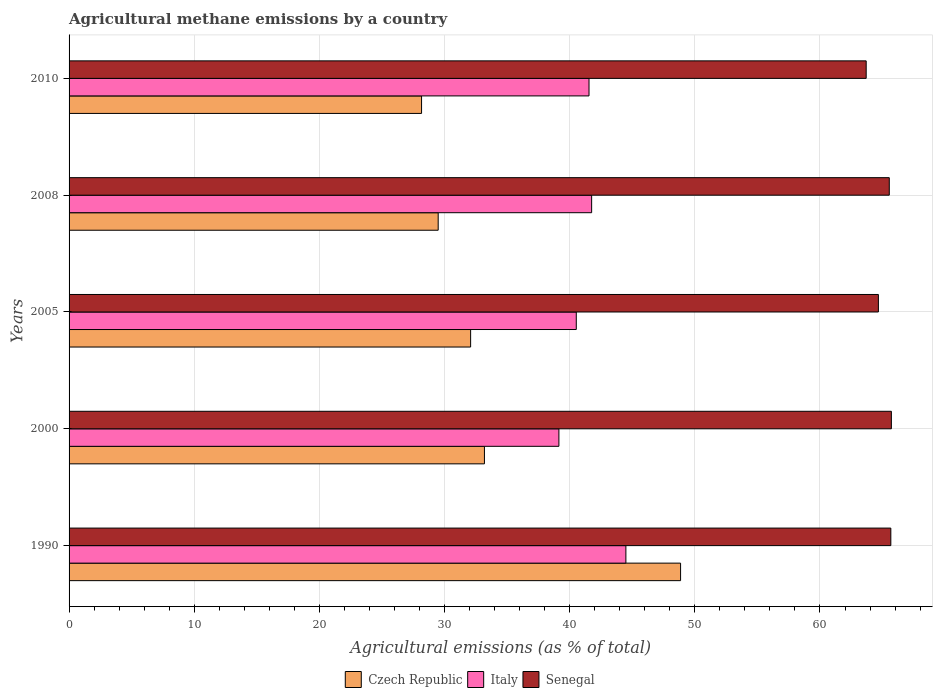How many groups of bars are there?
Your answer should be compact. 5. Are the number of bars on each tick of the Y-axis equal?
Make the answer very short. Yes. How many bars are there on the 4th tick from the bottom?
Give a very brief answer. 3. What is the amount of agricultural methane emitted in Senegal in 2000?
Offer a terse response. 65.71. Across all years, what is the maximum amount of agricultural methane emitted in Italy?
Give a very brief answer. 44.49. Across all years, what is the minimum amount of agricultural methane emitted in Italy?
Ensure brevity in your answer.  39.14. In which year was the amount of agricultural methane emitted in Czech Republic maximum?
Provide a short and direct response. 1990. What is the total amount of agricultural methane emitted in Senegal in the graph?
Provide a succinct answer. 325.27. What is the difference between the amount of agricultural methane emitted in Senegal in 2008 and that in 2010?
Your response must be concise. 1.85. What is the difference between the amount of agricultural methane emitted in Czech Republic in 1990 and the amount of agricultural methane emitted in Italy in 2008?
Offer a terse response. 7.11. What is the average amount of agricultural methane emitted in Czech Republic per year?
Keep it short and to the point. 34.36. In the year 1990, what is the difference between the amount of agricultural methane emitted in Czech Republic and amount of agricultural methane emitted in Senegal?
Provide a short and direct response. -16.8. What is the ratio of the amount of agricultural methane emitted in Italy in 2005 to that in 2010?
Give a very brief answer. 0.98. Is the amount of agricultural methane emitted in Senegal in 2005 less than that in 2008?
Your answer should be very brief. Yes. Is the difference between the amount of agricultural methane emitted in Czech Republic in 1990 and 2005 greater than the difference between the amount of agricultural methane emitted in Senegal in 1990 and 2005?
Offer a terse response. Yes. What is the difference between the highest and the second highest amount of agricultural methane emitted in Italy?
Provide a short and direct response. 2.74. What is the difference between the highest and the lowest amount of agricultural methane emitted in Czech Republic?
Ensure brevity in your answer.  20.7. Is the sum of the amount of agricultural methane emitted in Senegal in 2008 and 2010 greater than the maximum amount of agricultural methane emitted in Czech Republic across all years?
Offer a very short reply. Yes. What does the 2nd bar from the top in 2000 represents?
Offer a very short reply. Italy. What does the 1st bar from the bottom in 2008 represents?
Your response must be concise. Czech Republic. Is it the case that in every year, the sum of the amount of agricultural methane emitted in Czech Republic and amount of agricultural methane emitted in Italy is greater than the amount of agricultural methane emitted in Senegal?
Offer a terse response. Yes. How many bars are there?
Ensure brevity in your answer.  15. Are all the bars in the graph horizontal?
Give a very brief answer. Yes. Does the graph contain any zero values?
Give a very brief answer. No. Does the graph contain grids?
Ensure brevity in your answer.  Yes. Where does the legend appear in the graph?
Your answer should be very brief. Bottom center. How are the legend labels stacked?
Offer a terse response. Horizontal. What is the title of the graph?
Keep it short and to the point. Agricultural methane emissions by a country. What is the label or title of the X-axis?
Your answer should be very brief. Agricultural emissions (as % of total). What is the Agricultural emissions (as % of total) in Czech Republic in 1990?
Your answer should be very brief. 48.86. What is the Agricultural emissions (as % of total) in Italy in 1990?
Give a very brief answer. 44.49. What is the Agricultural emissions (as % of total) of Senegal in 1990?
Offer a very short reply. 65.66. What is the Agricultural emissions (as % of total) of Czech Republic in 2000?
Your response must be concise. 33.19. What is the Agricultural emissions (as % of total) of Italy in 2000?
Offer a very short reply. 39.14. What is the Agricultural emissions (as % of total) of Senegal in 2000?
Provide a succinct answer. 65.71. What is the Agricultural emissions (as % of total) of Czech Republic in 2005?
Your answer should be compact. 32.09. What is the Agricultural emissions (as % of total) of Italy in 2005?
Your answer should be compact. 40.53. What is the Agricultural emissions (as % of total) in Senegal in 2005?
Offer a terse response. 64.67. What is the Agricultural emissions (as % of total) in Czech Republic in 2008?
Your response must be concise. 29.49. What is the Agricultural emissions (as % of total) in Italy in 2008?
Your response must be concise. 41.76. What is the Agricultural emissions (as % of total) in Senegal in 2008?
Give a very brief answer. 65.54. What is the Agricultural emissions (as % of total) of Czech Republic in 2010?
Keep it short and to the point. 28.17. What is the Agricultural emissions (as % of total) in Italy in 2010?
Give a very brief answer. 41.55. What is the Agricultural emissions (as % of total) of Senegal in 2010?
Provide a short and direct response. 63.69. Across all years, what is the maximum Agricultural emissions (as % of total) of Czech Republic?
Provide a short and direct response. 48.86. Across all years, what is the maximum Agricultural emissions (as % of total) of Italy?
Make the answer very short. 44.49. Across all years, what is the maximum Agricultural emissions (as % of total) in Senegal?
Ensure brevity in your answer.  65.71. Across all years, what is the minimum Agricultural emissions (as % of total) of Czech Republic?
Provide a short and direct response. 28.17. Across all years, what is the minimum Agricultural emissions (as % of total) in Italy?
Keep it short and to the point. 39.14. Across all years, what is the minimum Agricultural emissions (as % of total) of Senegal?
Provide a short and direct response. 63.69. What is the total Agricultural emissions (as % of total) in Czech Republic in the graph?
Make the answer very short. 171.8. What is the total Agricultural emissions (as % of total) in Italy in the graph?
Your response must be concise. 207.46. What is the total Agricultural emissions (as % of total) of Senegal in the graph?
Make the answer very short. 325.27. What is the difference between the Agricultural emissions (as % of total) of Czech Republic in 1990 and that in 2000?
Your response must be concise. 15.67. What is the difference between the Agricultural emissions (as % of total) of Italy in 1990 and that in 2000?
Your response must be concise. 5.35. What is the difference between the Agricultural emissions (as % of total) of Senegal in 1990 and that in 2000?
Your response must be concise. -0.04. What is the difference between the Agricultural emissions (as % of total) of Czech Republic in 1990 and that in 2005?
Make the answer very short. 16.78. What is the difference between the Agricultural emissions (as % of total) of Italy in 1990 and that in 2005?
Offer a very short reply. 3.96. What is the difference between the Agricultural emissions (as % of total) in Senegal in 1990 and that in 2005?
Offer a terse response. 0.99. What is the difference between the Agricultural emissions (as % of total) of Czech Republic in 1990 and that in 2008?
Offer a very short reply. 19.37. What is the difference between the Agricultural emissions (as % of total) in Italy in 1990 and that in 2008?
Make the answer very short. 2.74. What is the difference between the Agricultural emissions (as % of total) of Senegal in 1990 and that in 2008?
Provide a succinct answer. 0.12. What is the difference between the Agricultural emissions (as % of total) in Czech Republic in 1990 and that in 2010?
Your answer should be very brief. 20.7. What is the difference between the Agricultural emissions (as % of total) in Italy in 1990 and that in 2010?
Your answer should be compact. 2.95. What is the difference between the Agricultural emissions (as % of total) in Senegal in 1990 and that in 2010?
Your answer should be very brief. 1.97. What is the difference between the Agricultural emissions (as % of total) of Czech Republic in 2000 and that in 2005?
Offer a very short reply. 1.1. What is the difference between the Agricultural emissions (as % of total) of Italy in 2000 and that in 2005?
Ensure brevity in your answer.  -1.39. What is the difference between the Agricultural emissions (as % of total) in Senegal in 2000 and that in 2005?
Ensure brevity in your answer.  1.04. What is the difference between the Agricultural emissions (as % of total) of Czech Republic in 2000 and that in 2008?
Make the answer very short. 3.69. What is the difference between the Agricultural emissions (as % of total) of Italy in 2000 and that in 2008?
Your answer should be compact. -2.62. What is the difference between the Agricultural emissions (as % of total) in Senegal in 2000 and that in 2008?
Offer a terse response. 0.17. What is the difference between the Agricultural emissions (as % of total) of Czech Republic in 2000 and that in 2010?
Offer a terse response. 5.02. What is the difference between the Agricultural emissions (as % of total) of Italy in 2000 and that in 2010?
Offer a very short reply. -2.41. What is the difference between the Agricultural emissions (as % of total) of Senegal in 2000 and that in 2010?
Make the answer very short. 2.01. What is the difference between the Agricultural emissions (as % of total) in Czech Republic in 2005 and that in 2008?
Your answer should be very brief. 2.59. What is the difference between the Agricultural emissions (as % of total) of Italy in 2005 and that in 2008?
Offer a very short reply. -1.23. What is the difference between the Agricultural emissions (as % of total) of Senegal in 2005 and that in 2008?
Offer a terse response. -0.87. What is the difference between the Agricultural emissions (as % of total) in Czech Republic in 2005 and that in 2010?
Keep it short and to the point. 3.92. What is the difference between the Agricultural emissions (as % of total) of Italy in 2005 and that in 2010?
Provide a short and direct response. -1.02. What is the difference between the Agricultural emissions (as % of total) of Senegal in 2005 and that in 2010?
Provide a short and direct response. 0.98. What is the difference between the Agricultural emissions (as % of total) in Czech Republic in 2008 and that in 2010?
Make the answer very short. 1.33. What is the difference between the Agricultural emissions (as % of total) in Italy in 2008 and that in 2010?
Keep it short and to the point. 0.21. What is the difference between the Agricultural emissions (as % of total) of Senegal in 2008 and that in 2010?
Provide a succinct answer. 1.85. What is the difference between the Agricultural emissions (as % of total) of Czech Republic in 1990 and the Agricultural emissions (as % of total) of Italy in 2000?
Give a very brief answer. 9.72. What is the difference between the Agricultural emissions (as % of total) in Czech Republic in 1990 and the Agricultural emissions (as % of total) in Senegal in 2000?
Your answer should be compact. -16.84. What is the difference between the Agricultural emissions (as % of total) in Italy in 1990 and the Agricultural emissions (as % of total) in Senegal in 2000?
Provide a short and direct response. -21.21. What is the difference between the Agricultural emissions (as % of total) in Czech Republic in 1990 and the Agricultural emissions (as % of total) in Italy in 2005?
Provide a short and direct response. 8.33. What is the difference between the Agricultural emissions (as % of total) in Czech Republic in 1990 and the Agricultural emissions (as % of total) in Senegal in 2005?
Offer a terse response. -15.81. What is the difference between the Agricultural emissions (as % of total) of Italy in 1990 and the Agricultural emissions (as % of total) of Senegal in 2005?
Offer a terse response. -20.18. What is the difference between the Agricultural emissions (as % of total) in Czech Republic in 1990 and the Agricultural emissions (as % of total) in Italy in 2008?
Provide a short and direct response. 7.11. What is the difference between the Agricultural emissions (as % of total) of Czech Republic in 1990 and the Agricultural emissions (as % of total) of Senegal in 2008?
Ensure brevity in your answer.  -16.68. What is the difference between the Agricultural emissions (as % of total) in Italy in 1990 and the Agricultural emissions (as % of total) in Senegal in 2008?
Offer a terse response. -21.05. What is the difference between the Agricultural emissions (as % of total) in Czech Republic in 1990 and the Agricultural emissions (as % of total) in Italy in 2010?
Offer a terse response. 7.32. What is the difference between the Agricultural emissions (as % of total) in Czech Republic in 1990 and the Agricultural emissions (as % of total) in Senegal in 2010?
Offer a very short reply. -14.83. What is the difference between the Agricultural emissions (as % of total) of Italy in 1990 and the Agricultural emissions (as % of total) of Senegal in 2010?
Give a very brief answer. -19.2. What is the difference between the Agricultural emissions (as % of total) of Czech Republic in 2000 and the Agricultural emissions (as % of total) of Italy in 2005?
Ensure brevity in your answer.  -7.34. What is the difference between the Agricultural emissions (as % of total) in Czech Republic in 2000 and the Agricultural emissions (as % of total) in Senegal in 2005?
Make the answer very short. -31.48. What is the difference between the Agricultural emissions (as % of total) of Italy in 2000 and the Agricultural emissions (as % of total) of Senegal in 2005?
Your answer should be compact. -25.53. What is the difference between the Agricultural emissions (as % of total) in Czech Republic in 2000 and the Agricultural emissions (as % of total) in Italy in 2008?
Your response must be concise. -8.57. What is the difference between the Agricultural emissions (as % of total) in Czech Republic in 2000 and the Agricultural emissions (as % of total) in Senegal in 2008?
Provide a short and direct response. -32.35. What is the difference between the Agricultural emissions (as % of total) in Italy in 2000 and the Agricultural emissions (as % of total) in Senegal in 2008?
Ensure brevity in your answer.  -26.4. What is the difference between the Agricultural emissions (as % of total) in Czech Republic in 2000 and the Agricultural emissions (as % of total) in Italy in 2010?
Offer a terse response. -8.36. What is the difference between the Agricultural emissions (as % of total) of Czech Republic in 2000 and the Agricultural emissions (as % of total) of Senegal in 2010?
Your answer should be very brief. -30.5. What is the difference between the Agricultural emissions (as % of total) of Italy in 2000 and the Agricultural emissions (as % of total) of Senegal in 2010?
Your response must be concise. -24.55. What is the difference between the Agricultural emissions (as % of total) in Czech Republic in 2005 and the Agricultural emissions (as % of total) in Italy in 2008?
Your response must be concise. -9.67. What is the difference between the Agricultural emissions (as % of total) in Czech Republic in 2005 and the Agricultural emissions (as % of total) in Senegal in 2008?
Give a very brief answer. -33.45. What is the difference between the Agricultural emissions (as % of total) in Italy in 2005 and the Agricultural emissions (as % of total) in Senegal in 2008?
Provide a short and direct response. -25.01. What is the difference between the Agricultural emissions (as % of total) in Czech Republic in 2005 and the Agricultural emissions (as % of total) in Italy in 2010?
Your response must be concise. -9.46. What is the difference between the Agricultural emissions (as % of total) in Czech Republic in 2005 and the Agricultural emissions (as % of total) in Senegal in 2010?
Provide a short and direct response. -31.61. What is the difference between the Agricultural emissions (as % of total) in Italy in 2005 and the Agricultural emissions (as % of total) in Senegal in 2010?
Your answer should be compact. -23.16. What is the difference between the Agricultural emissions (as % of total) of Czech Republic in 2008 and the Agricultural emissions (as % of total) of Italy in 2010?
Your response must be concise. -12.05. What is the difference between the Agricultural emissions (as % of total) of Czech Republic in 2008 and the Agricultural emissions (as % of total) of Senegal in 2010?
Provide a short and direct response. -34.2. What is the difference between the Agricultural emissions (as % of total) of Italy in 2008 and the Agricultural emissions (as % of total) of Senegal in 2010?
Give a very brief answer. -21.94. What is the average Agricultural emissions (as % of total) of Czech Republic per year?
Keep it short and to the point. 34.36. What is the average Agricultural emissions (as % of total) of Italy per year?
Keep it short and to the point. 41.49. What is the average Agricultural emissions (as % of total) in Senegal per year?
Ensure brevity in your answer.  65.05. In the year 1990, what is the difference between the Agricultural emissions (as % of total) of Czech Republic and Agricultural emissions (as % of total) of Italy?
Your answer should be very brief. 4.37. In the year 1990, what is the difference between the Agricultural emissions (as % of total) of Czech Republic and Agricultural emissions (as % of total) of Senegal?
Give a very brief answer. -16.8. In the year 1990, what is the difference between the Agricultural emissions (as % of total) of Italy and Agricultural emissions (as % of total) of Senegal?
Offer a very short reply. -21.17. In the year 2000, what is the difference between the Agricultural emissions (as % of total) in Czech Republic and Agricultural emissions (as % of total) in Italy?
Keep it short and to the point. -5.95. In the year 2000, what is the difference between the Agricultural emissions (as % of total) in Czech Republic and Agricultural emissions (as % of total) in Senegal?
Your answer should be very brief. -32.52. In the year 2000, what is the difference between the Agricultural emissions (as % of total) in Italy and Agricultural emissions (as % of total) in Senegal?
Your answer should be compact. -26.57. In the year 2005, what is the difference between the Agricultural emissions (as % of total) in Czech Republic and Agricultural emissions (as % of total) in Italy?
Give a very brief answer. -8.44. In the year 2005, what is the difference between the Agricultural emissions (as % of total) of Czech Republic and Agricultural emissions (as % of total) of Senegal?
Keep it short and to the point. -32.58. In the year 2005, what is the difference between the Agricultural emissions (as % of total) in Italy and Agricultural emissions (as % of total) in Senegal?
Offer a terse response. -24.14. In the year 2008, what is the difference between the Agricultural emissions (as % of total) in Czech Republic and Agricultural emissions (as % of total) in Italy?
Give a very brief answer. -12.26. In the year 2008, what is the difference between the Agricultural emissions (as % of total) in Czech Republic and Agricultural emissions (as % of total) in Senegal?
Ensure brevity in your answer.  -36.04. In the year 2008, what is the difference between the Agricultural emissions (as % of total) of Italy and Agricultural emissions (as % of total) of Senegal?
Offer a very short reply. -23.78. In the year 2010, what is the difference between the Agricultural emissions (as % of total) in Czech Republic and Agricultural emissions (as % of total) in Italy?
Ensure brevity in your answer.  -13.38. In the year 2010, what is the difference between the Agricultural emissions (as % of total) of Czech Republic and Agricultural emissions (as % of total) of Senegal?
Keep it short and to the point. -35.53. In the year 2010, what is the difference between the Agricultural emissions (as % of total) of Italy and Agricultural emissions (as % of total) of Senegal?
Give a very brief answer. -22.15. What is the ratio of the Agricultural emissions (as % of total) of Czech Republic in 1990 to that in 2000?
Give a very brief answer. 1.47. What is the ratio of the Agricultural emissions (as % of total) of Italy in 1990 to that in 2000?
Make the answer very short. 1.14. What is the ratio of the Agricultural emissions (as % of total) of Senegal in 1990 to that in 2000?
Give a very brief answer. 1. What is the ratio of the Agricultural emissions (as % of total) in Czech Republic in 1990 to that in 2005?
Your response must be concise. 1.52. What is the ratio of the Agricultural emissions (as % of total) of Italy in 1990 to that in 2005?
Provide a succinct answer. 1.1. What is the ratio of the Agricultural emissions (as % of total) of Senegal in 1990 to that in 2005?
Keep it short and to the point. 1.02. What is the ratio of the Agricultural emissions (as % of total) of Czech Republic in 1990 to that in 2008?
Your answer should be very brief. 1.66. What is the ratio of the Agricultural emissions (as % of total) of Italy in 1990 to that in 2008?
Keep it short and to the point. 1.07. What is the ratio of the Agricultural emissions (as % of total) in Czech Republic in 1990 to that in 2010?
Provide a succinct answer. 1.73. What is the ratio of the Agricultural emissions (as % of total) of Italy in 1990 to that in 2010?
Provide a succinct answer. 1.07. What is the ratio of the Agricultural emissions (as % of total) in Senegal in 1990 to that in 2010?
Make the answer very short. 1.03. What is the ratio of the Agricultural emissions (as % of total) in Czech Republic in 2000 to that in 2005?
Provide a succinct answer. 1.03. What is the ratio of the Agricultural emissions (as % of total) in Italy in 2000 to that in 2005?
Make the answer very short. 0.97. What is the ratio of the Agricultural emissions (as % of total) of Czech Republic in 2000 to that in 2008?
Provide a short and direct response. 1.13. What is the ratio of the Agricultural emissions (as % of total) of Italy in 2000 to that in 2008?
Your response must be concise. 0.94. What is the ratio of the Agricultural emissions (as % of total) in Senegal in 2000 to that in 2008?
Offer a terse response. 1. What is the ratio of the Agricultural emissions (as % of total) in Czech Republic in 2000 to that in 2010?
Offer a terse response. 1.18. What is the ratio of the Agricultural emissions (as % of total) of Italy in 2000 to that in 2010?
Offer a terse response. 0.94. What is the ratio of the Agricultural emissions (as % of total) of Senegal in 2000 to that in 2010?
Your response must be concise. 1.03. What is the ratio of the Agricultural emissions (as % of total) in Czech Republic in 2005 to that in 2008?
Your answer should be very brief. 1.09. What is the ratio of the Agricultural emissions (as % of total) in Italy in 2005 to that in 2008?
Your response must be concise. 0.97. What is the ratio of the Agricultural emissions (as % of total) in Senegal in 2005 to that in 2008?
Give a very brief answer. 0.99. What is the ratio of the Agricultural emissions (as % of total) of Czech Republic in 2005 to that in 2010?
Make the answer very short. 1.14. What is the ratio of the Agricultural emissions (as % of total) of Italy in 2005 to that in 2010?
Offer a terse response. 0.98. What is the ratio of the Agricultural emissions (as % of total) in Senegal in 2005 to that in 2010?
Ensure brevity in your answer.  1.02. What is the ratio of the Agricultural emissions (as % of total) in Czech Republic in 2008 to that in 2010?
Your response must be concise. 1.05. What is the ratio of the Agricultural emissions (as % of total) in Italy in 2008 to that in 2010?
Your answer should be compact. 1. What is the difference between the highest and the second highest Agricultural emissions (as % of total) in Czech Republic?
Your response must be concise. 15.67. What is the difference between the highest and the second highest Agricultural emissions (as % of total) in Italy?
Your response must be concise. 2.74. What is the difference between the highest and the second highest Agricultural emissions (as % of total) of Senegal?
Make the answer very short. 0.04. What is the difference between the highest and the lowest Agricultural emissions (as % of total) in Czech Republic?
Offer a very short reply. 20.7. What is the difference between the highest and the lowest Agricultural emissions (as % of total) in Italy?
Make the answer very short. 5.35. What is the difference between the highest and the lowest Agricultural emissions (as % of total) of Senegal?
Your answer should be compact. 2.01. 